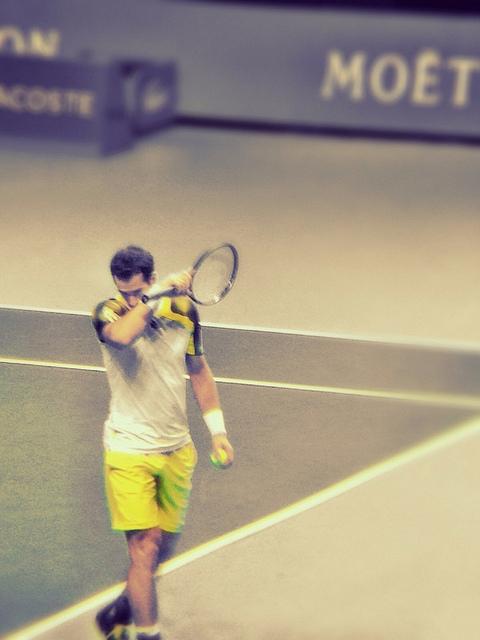What items is the man holding?
Write a very short answer. Tennis racket. Is tennis an athletic sport?
Write a very short answer. Yes. What color is the court?
Be succinct. Gray. Looking at his thigh, does the man show signs of physical exertion?
Answer briefly. Yes. 